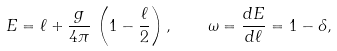Convert formula to latex. <formula><loc_0><loc_0><loc_500><loc_500>E = \ell + \frac { g } { 4 \pi } \, \left ( 1 - \frac { \ell } { 2 } \right ) , \quad \omega = \frac { d E } { d \ell } = 1 - \delta ,</formula> 